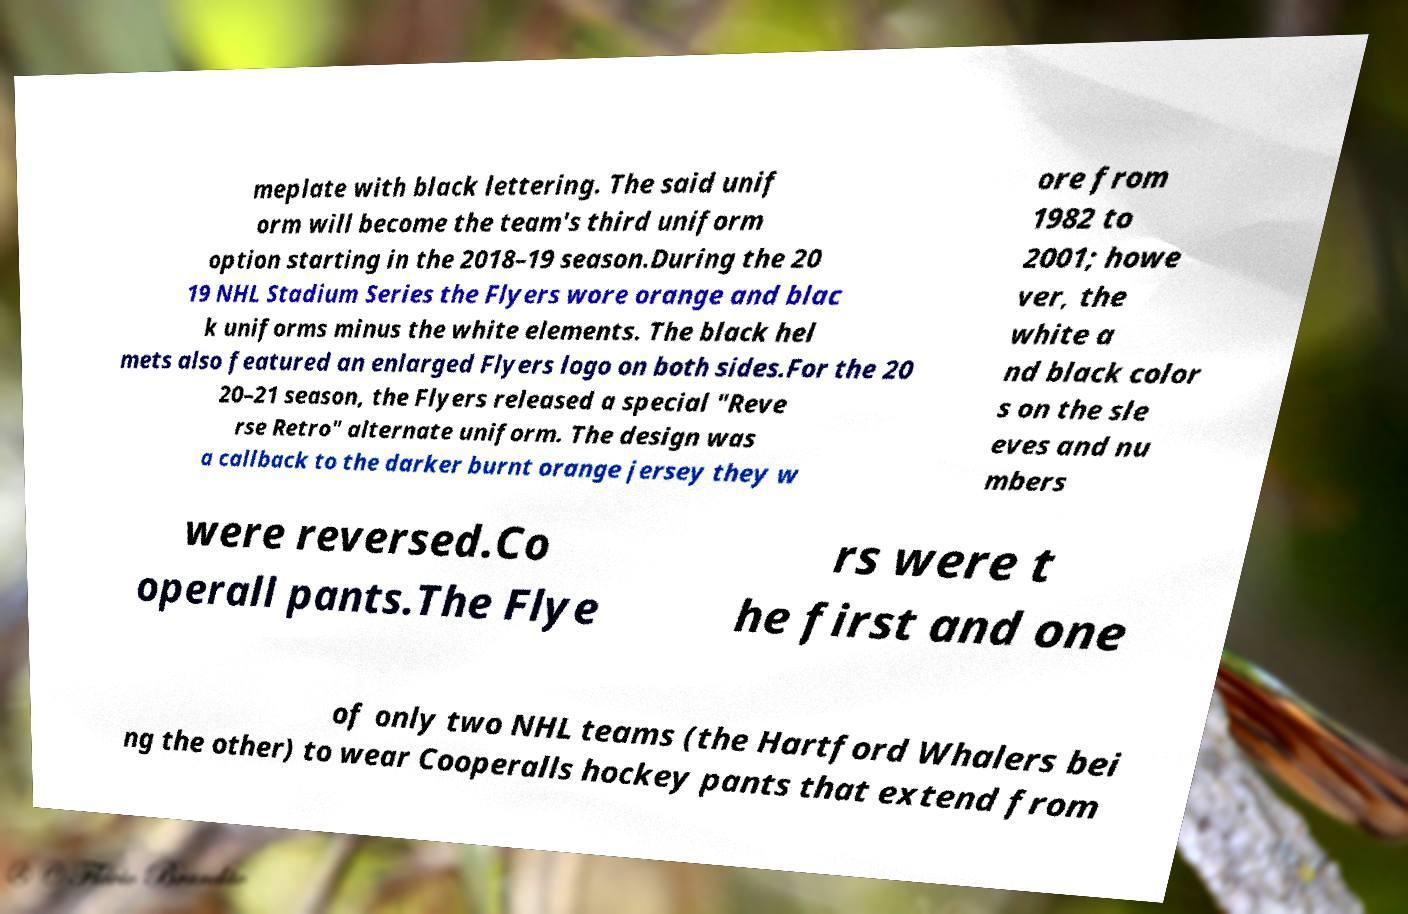Please identify and transcribe the text found in this image. meplate with black lettering. The said unif orm will become the team's third uniform option starting in the 2018–19 season.During the 20 19 NHL Stadium Series the Flyers wore orange and blac k uniforms minus the white elements. The black hel mets also featured an enlarged Flyers logo on both sides.For the 20 20–21 season, the Flyers released a special "Reve rse Retro" alternate uniform. The design was a callback to the darker burnt orange jersey they w ore from 1982 to 2001; howe ver, the white a nd black color s on the sle eves and nu mbers were reversed.Co operall pants.The Flye rs were t he first and one of only two NHL teams (the Hartford Whalers bei ng the other) to wear Cooperalls hockey pants that extend from 